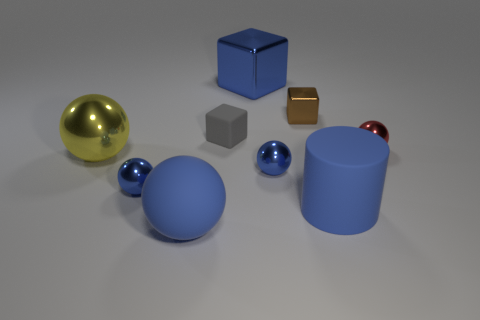Subtract all brown cubes. How many cubes are left? 2 Subtract all brown blocks. How many blue spheres are left? 3 Add 1 matte cylinders. How many objects exist? 10 Subtract 2 blocks. How many blocks are left? 1 Subtract all blue balls. How many balls are left? 2 Subtract all cylinders. How many objects are left? 8 Subtract all blue blocks. Subtract all green spheres. How many blocks are left? 2 Subtract all cylinders. Subtract all tiny brown objects. How many objects are left? 7 Add 2 blocks. How many blocks are left? 5 Add 9 tiny brown shiny blocks. How many tiny brown shiny blocks exist? 10 